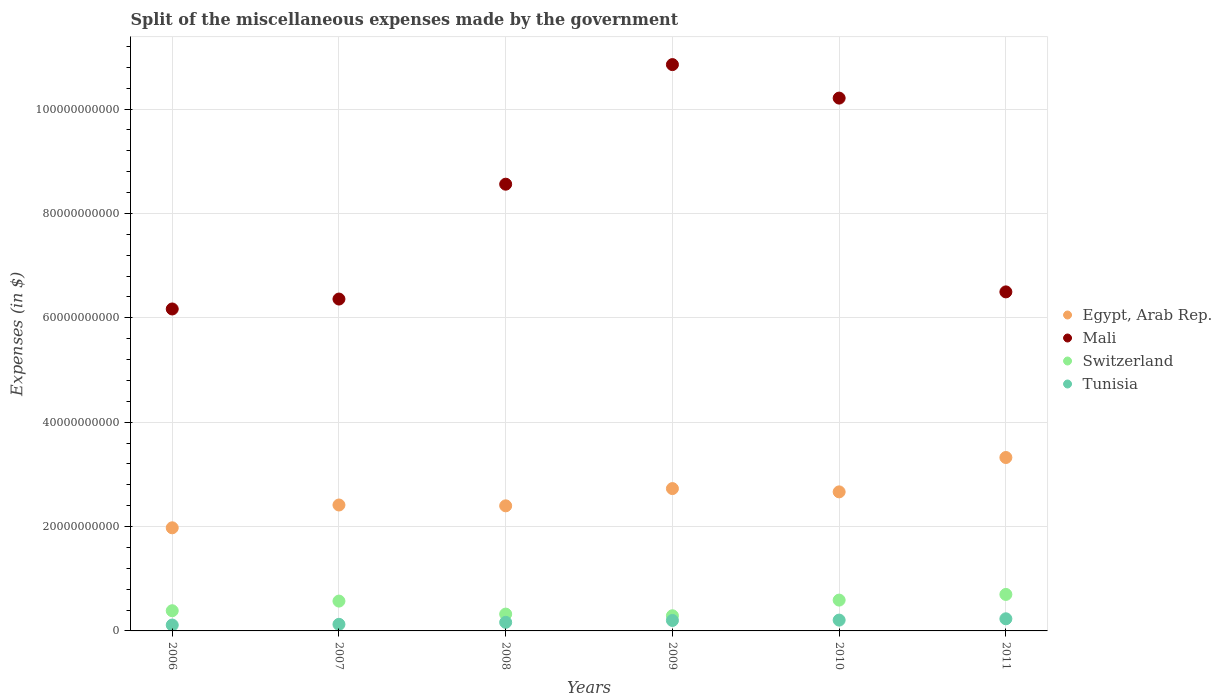How many different coloured dotlines are there?
Make the answer very short. 4. What is the miscellaneous expenses made by the government in Tunisia in 2010?
Provide a short and direct response. 2.07e+09. Across all years, what is the maximum miscellaneous expenses made by the government in Tunisia?
Your response must be concise. 2.32e+09. Across all years, what is the minimum miscellaneous expenses made by the government in Tunisia?
Your answer should be compact. 1.13e+09. In which year was the miscellaneous expenses made by the government in Switzerland minimum?
Ensure brevity in your answer.  2009. What is the total miscellaneous expenses made by the government in Mali in the graph?
Keep it short and to the point. 4.87e+11. What is the difference between the miscellaneous expenses made by the government in Tunisia in 2007 and that in 2008?
Keep it short and to the point. -3.80e+08. What is the difference between the miscellaneous expenses made by the government in Tunisia in 2006 and the miscellaneous expenses made by the government in Egypt, Arab Rep. in 2010?
Your answer should be compact. -2.55e+1. What is the average miscellaneous expenses made by the government in Mali per year?
Provide a succinct answer. 8.11e+1. In the year 2009, what is the difference between the miscellaneous expenses made by the government in Mali and miscellaneous expenses made by the government in Tunisia?
Your answer should be very brief. 1.07e+11. In how many years, is the miscellaneous expenses made by the government in Switzerland greater than 100000000000 $?
Your answer should be compact. 0. What is the ratio of the miscellaneous expenses made by the government in Mali in 2006 to that in 2007?
Your response must be concise. 0.97. Is the difference between the miscellaneous expenses made by the government in Mali in 2007 and 2009 greater than the difference between the miscellaneous expenses made by the government in Tunisia in 2007 and 2009?
Your answer should be compact. No. What is the difference between the highest and the second highest miscellaneous expenses made by the government in Switzerland?
Your response must be concise. 1.09e+09. What is the difference between the highest and the lowest miscellaneous expenses made by the government in Switzerland?
Offer a very short reply. 4.09e+09. Is the sum of the miscellaneous expenses made by the government in Tunisia in 2006 and 2008 greater than the maximum miscellaneous expenses made by the government in Switzerland across all years?
Give a very brief answer. No. Is it the case that in every year, the sum of the miscellaneous expenses made by the government in Switzerland and miscellaneous expenses made by the government in Egypt, Arab Rep.  is greater than the sum of miscellaneous expenses made by the government in Tunisia and miscellaneous expenses made by the government in Mali?
Offer a terse response. Yes. Does the miscellaneous expenses made by the government in Tunisia monotonically increase over the years?
Your answer should be compact. Yes. How many dotlines are there?
Offer a terse response. 4. How many years are there in the graph?
Give a very brief answer. 6. Are the values on the major ticks of Y-axis written in scientific E-notation?
Provide a short and direct response. No. Does the graph contain any zero values?
Your answer should be compact. No. Does the graph contain grids?
Make the answer very short. Yes. What is the title of the graph?
Your answer should be very brief. Split of the miscellaneous expenses made by the government. What is the label or title of the Y-axis?
Give a very brief answer. Expenses (in $). What is the Expenses (in $) of Egypt, Arab Rep. in 2006?
Your answer should be compact. 1.98e+1. What is the Expenses (in $) in Mali in 2006?
Your answer should be compact. 6.17e+1. What is the Expenses (in $) of Switzerland in 2006?
Your answer should be very brief. 3.87e+09. What is the Expenses (in $) of Tunisia in 2006?
Provide a succinct answer. 1.13e+09. What is the Expenses (in $) in Egypt, Arab Rep. in 2007?
Offer a terse response. 2.41e+1. What is the Expenses (in $) of Mali in 2007?
Your answer should be compact. 6.36e+1. What is the Expenses (in $) in Switzerland in 2007?
Your response must be concise. 5.72e+09. What is the Expenses (in $) of Tunisia in 2007?
Your answer should be compact. 1.26e+09. What is the Expenses (in $) of Egypt, Arab Rep. in 2008?
Give a very brief answer. 2.40e+1. What is the Expenses (in $) in Mali in 2008?
Offer a very short reply. 8.56e+1. What is the Expenses (in $) in Switzerland in 2008?
Offer a terse response. 3.22e+09. What is the Expenses (in $) of Tunisia in 2008?
Give a very brief answer. 1.64e+09. What is the Expenses (in $) in Egypt, Arab Rep. in 2009?
Provide a succinct answer. 2.73e+1. What is the Expenses (in $) in Mali in 2009?
Make the answer very short. 1.09e+11. What is the Expenses (in $) of Switzerland in 2009?
Make the answer very short. 2.91e+09. What is the Expenses (in $) of Tunisia in 2009?
Your answer should be very brief. 2.00e+09. What is the Expenses (in $) of Egypt, Arab Rep. in 2010?
Give a very brief answer. 2.66e+1. What is the Expenses (in $) of Mali in 2010?
Offer a terse response. 1.02e+11. What is the Expenses (in $) in Switzerland in 2010?
Your answer should be compact. 5.91e+09. What is the Expenses (in $) of Tunisia in 2010?
Give a very brief answer. 2.07e+09. What is the Expenses (in $) of Egypt, Arab Rep. in 2011?
Give a very brief answer. 3.32e+1. What is the Expenses (in $) in Mali in 2011?
Provide a succinct answer. 6.50e+1. What is the Expenses (in $) in Switzerland in 2011?
Provide a succinct answer. 6.99e+09. What is the Expenses (in $) of Tunisia in 2011?
Make the answer very short. 2.32e+09. Across all years, what is the maximum Expenses (in $) of Egypt, Arab Rep.?
Provide a short and direct response. 3.32e+1. Across all years, what is the maximum Expenses (in $) of Mali?
Your response must be concise. 1.09e+11. Across all years, what is the maximum Expenses (in $) of Switzerland?
Give a very brief answer. 6.99e+09. Across all years, what is the maximum Expenses (in $) of Tunisia?
Your answer should be compact. 2.32e+09. Across all years, what is the minimum Expenses (in $) in Egypt, Arab Rep.?
Provide a succinct answer. 1.98e+1. Across all years, what is the minimum Expenses (in $) of Mali?
Give a very brief answer. 6.17e+1. Across all years, what is the minimum Expenses (in $) of Switzerland?
Offer a terse response. 2.91e+09. Across all years, what is the minimum Expenses (in $) of Tunisia?
Give a very brief answer. 1.13e+09. What is the total Expenses (in $) of Egypt, Arab Rep. in the graph?
Give a very brief answer. 1.55e+11. What is the total Expenses (in $) of Mali in the graph?
Your answer should be compact. 4.87e+11. What is the total Expenses (in $) of Switzerland in the graph?
Your answer should be compact. 2.86e+1. What is the total Expenses (in $) in Tunisia in the graph?
Give a very brief answer. 1.04e+1. What is the difference between the Expenses (in $) in Egypt, Arab Rep. in 2006 and that in 2007?
Ensure brevity in your answer.  -4.37e+09. What is the difference between the Expenses (in $) in Mali in 2006 and that in 2007?
Your answer should be compact. -1.90e+09. What is the difference between the Expenses (in $) in Switzerland in 2006 and that in 2007?
Ensure brevity in your answer.  -1.85e+09. What is the difference between the Expenses (in $) of Tunisia in 2006 and that in 2007?
Your answer should be compact. -1.37e+08. What is the difference between the Expenses (in $) of Egypt, Arab Rep. in 2006 and that in 2008?
Provide a short and direct response. -4.21e+09. What is the difference between the Expenses (in $) of Mali in 2006 and that in 2008?
Your answer should be very brief. -2.39e+1. What is the difference between the Expenses (in $) of Switzerland in 2006 and that in 2008?
Give a very brief answer. 6.45e+08. What is the difference between the Expenses (in $) of Tunisia in 2006 and that in 2008?
Provide a succinct answer. -5.17e+08. What is the difference between the Expenses (in $) of Egypt, Arab Rep. in 2006 and that in 2009?
Your answer should be compact. -7.51e+09. What is the difference between the Expenses (in $) in Mali in 2006 and that in 2009?
Provide a succinct answer. -4.68e+1. What is the difference between the Expenses (in $) of Switzerland in 2006 and that in 2009?
Offer a very short reply. 9.64e+08. What is the difference between the Expenses (in $) in Tunisia in 2006 and that in 2009?
Provide a short and direct response. -8.77e+08. What is the difference between the Expenses (in $) of Egypt, Arab Rep. in 2006 and that in 2010?
Offer a terse response. -6.89e+09. What is the difference between the Expenses (in $) in Mali in 2006 and that in 2010?
Make the answer very short. -4.04e+1. What is the difference between the Expenses (in $) in Switzerland in 2006 and that in 2010?
Give a very brief answer. -2.04e+09. What is the difference between the Expenses (in $) of Tunisia in 2006 and that in 2010?
Your response must be concise. -9.48e+08. What is the difference between the Expenses (in $) of Egypt, Arab Rep. in 2006 and that in 2011?
Provide a short and direct response. -1.35e+1. What is the difference between the Expenses (in $) of Mali in 2006 and that in 2011?
Your response must be concise. -3.27e+09. What is the difference between the Expenses (in $) in Switzerland in 2006 and that in 2011?
Ensure brevity in your answer.  -3.12e+09. What is the difference between the Expenses (in $) of Tunisia in 2006 and that in 2011?
Keep it short and to the point. -1.20e+09. What is the difference between the Expenses (in $) in Egypt, Arab Rep. in 2007 and that in 2008?
Offer a terse response. 1.59e+08. What is the difference between the Expenses (in $) of Mali in 2007 and that in 2008?
Provide a short and direct response. -2.20e+1. What is the difference between the Expenses (in $) in Switzerland in 2007 and that in 2008?
Ensure brevity in your answer.  2.49e+09. What is the difference between the Expenses (in $) in Tunisia in 2007 and that in 2008?
Provide a succinct answer. -3.80e+08. What is the difference between the Expenses (in $) of Egypt, Arab Rep. in 2007 and that in 2009?
Offer a very short reply. -3.14e+09. What is the difference between the Expenses (in $) of Mali in 2007 and that in 2009?
Provide a short and direct response. -4.49e+1. What is the difference between the Expenses (in $) of Switzerland in 2007 and that in 2009?
Keep it short and to the point. 2.81e+09. What is the difference between the Expenses (in $) in Tunisia in 2007 and that in 2009?
Provide a short and direct response. -7.40e+08. What is the difference between the Expenses (in $) of Egypt, Arab Rep. in 2007 and that in 2010?
Your answer should be compact. -2.52e+09. What is the difference between the Expenses (in $) in Mali in 2007 and that in 2010?
Your answer should be very brief. -3.85e+1. What is the difference between the Expenses (in $) in Switzerland in 2007 and that in 2010?
Your answer should be compact. -1.89e+08. What is the difference between the Expenses (in $) in Tunisia in 2007 and that in 2010?
Your answer should be compact. -8.11e+08. What is the difference between the Expenses (in $) of Egypt, Arab Rep. in 2007 and that in 2011?
Your answer should be compact. -9.10e+09. What is the difference between the Expenses (in $) of Mali in 2007 and that in 2011?
Offer a very short reply. -1.37e+09. What is the difference between the Expenses (in $) of Switzerland in 2007 and that in 2011?
Make the answer very short. -1.28e+09. What is the difference between the Expenses (in $) in Tunisia in 2007 and that in 2011?
Your answer should be compact. -1.06e+09. What is the difference between the Expenses (in $) in Egypt, Arab Rep. in 2008 and that in 2009?
Your answer should be very brief. -3.30e+09. What is the difference between the Expenses (in $) of Mali in 2008 and that in 2009?
Keep it short and to the point. -2.29e+1. What is the difference between the Expenses (in $) of Switzerland in 2008 and that in 2009?
Offer a very short reply. 3.19e+08. What is the difference between the Expenses (in $) in Tunisia in 2008 and that in 2009?
Your answer should be very brief. -3.60e+08. What is the difference between the Expenses (in $) of Egypt, Arab Rep. in 2008 and that in 2010?
Provide a succinct answer. -2.67e+09. What is the difference between the Expenses (in $) in Mali in 2008 and that in 2010?
Provide a succinct answer. -1.65e+1. What is the difference between the Expenses (in $) in Switzerland in 2008 and that in 2010?
Provide a succinct answer. -2.68e+09. What is the difference between the Expenses (in $) in Tunisia in 2008 and that in 2010?
Keep it short and to the point. -4.31e+08. What is the difference between the Expenses (in $) of Egypt, Arab Rep. in 2008 and that in 2011?
Provide a short and direct response. -9.26e+09. What is the difference between the Expenses (in $) of Mali in 2008 and that in 2011?
Offer a terse response. 2.06e+1. What is the difference between the Expenses (in $) in Switzerland in 2008 and that in 2011?
Provide a succinct answer. -3.77e+09. What is the difference between the Expenses (in $) in Tunisia in 2008 and that in 2011?
Provide a succinct answer. -6.82e+08. What is the difference between the Expenses (in $) in Egypt, Arab Rep. in 2009 and that in 2010?
Your answer should be very brief. 6.29e+08. What is the difference between the Expenses (in $) of Mali in 2009 and that in 2010?
Offer a very short reply. 6.42e+09. What is the difference between the Expenses (in $) in Switzerland in 2009 and that in 2010?
Make the answer very short. -3.00e+09. What is the difference between the Expenses (in $) in Tunisia in 2009 and that in 2010?
Give a very brief answer. -7.06e+07. What is the difference between the Expenses (in $) of Egypt, Arab Rep. in 2009 and that in 2011?
Provide a short and direct response. -5.96e+09. What is the difference between the Expenses (in $) of Mali in 2009 and that in 2011?
Ensure brevity in your answer.  4.36e+1. What is the difference between the Expenses (in $) of Switzerland in 2009 and that in 2011?
Your response must be concise. -4.09e+09. What is the difference between the Expenses (in $) of Tunisia in 2009 and that in 2011?
Provide a short and direct response. -3.21e+08. What is the difference between the Expenses (in $) of Egypt, Arab Rep. in 2010 and that in 2011?
Offer a very short reply. -6.59e+09. What is the difference between the Expenses (in $) in Mali in 2010 and that in 2011?
Offer a very short reply. 3.71e+1. What is the difference between the Expenses (in $) in Switzerland in 2010 and that in 2011?
Provide a short and direct response. -1.09e+09. What is the difference between the Expenses (in $) of Tunisia in 2010 and that in 2011?
Make the answer very short. -2.50e+08. What is the difference between the Expenses (in $) of Egypt, Arab Rep. in 2006 and the Expenses (in $) of Mali in 2007?
Your response must be concise. -4.38e+1. What is the difference between the Expenses (in $) in Egypt, Arab Rep. in 2006 and the Expenses (in $) in Switzerland in 2007?
Provide a short and direct response. 1.40e+1. What is the difference between the Expenses (in $) in Egypt, Arab Rep. in 2006 and the Expenses (in $) in Tunisia in 2007?
Provide a short and direct response. 1.85e+1. What is the difference between the Expenses (in $) of Mali in 2006 and the Expenses (in $) of Switzerland in 2007?
Provide a succinct answer. 5.60e+1. What is the difference between the Expenses (in $) of Mali in 2006 and the Expenses (in $) of Tunisia in 2007?
Your answer should be very brief. 6.04e+1. What is the difference between the Expenses (in $) in Switzerland in 2006 and the Expenses (in $) in Tunisia in 2007?
Offer a terse response. 2.61e+09. What is the difference between the Expenses (in $) of Egypt, Arab Rep. in 2006 and the Expenses (in $) of Mali in 2008?
Your answer should be compact. -6.58e+1. What is the difference between the Expenses (in $) in Egypt, Arab Rep. in 2006 and the Expenses (in $) in Switzerland in 2008?
Make the answer very short. 1.65e+1. What is the difference between the Expenses (in $) of Egypt, Arab Rep. in 2006 and the Expenses (in $) of Tunisia in 2008?
Your answer should be compact. 1.81e+1. What is the difference between the Expenses (in $) in Mali in 2006 and the Expenses (in $) in Switzerland in 2008?
Offer a terse response. 5.85e+1. What is the difference between the Expenses (in $) in Mali in 2006 and the Expenses (in $) in Tunisia in 2008?
Provide a short and direct response. 6.01e+1. What is the difference between the Expenses (in $) of Switzerland in 2006 and the Expenses (in $) of Tunisia in 2008?
Provide a succinct answer. 2.23e+09. What is the difference between the Expenses (in $) of Egypt, Arab Rep. in 2006 and the Expenses (in $) of Mali in 2009?
Make the answer very short. -8.88e+1. What is the difference between the Expenses (in $) in Egypt, Arab Rep. in 2006 and the Expenses (in $) in Switzerland in 2009?
Your answer should be compact. 1.69e+1. What is the difference between the Expenses (in $) of Egypt, Arab Rep. in 2006 and the Expenses (in $) of Tunisia in 2009?
Make the answer very short. 1.78e+1. What is the difference between the Expenses (in $) in Mali in 2006 and the Expenses (in $) in Switzerland in 2009?
Your answer should be very brief. 5.88e+1. What is the difference between the Expenses (in $) in Mali in 2006 and the Expenses (in $) in Tunisia in 2009?
Your response must be concise. 5.97e+1. What is the difference between the Expenses (in $) in Switzerland in 2006 and the Expenses (in $) in Tunisia in 2009?
Keep it short and to the point. 1.87e+09. What is the difference between the Expenses (in $) in Egypt, Arab Rep. in 2006 and the Expenses (in $) in Mali in 2010?
Keep it short and to the point. -8.23e+1. What is the difference between the Expenses (in $) in Egypt, Arab Rep. in 2006 and the Expenses (in $) in Switzerland in 2010?
Make the answer very short. 1.39e+1. What is the difference between the Expenses (in $) in Egypt, Arab Rep. in 2006 and the Expenses (in $) in Tunisia in 2010?
Your response must be concise. 1.77e+1. What is the difference between the Expenses (in $) in Mali in 2006 and the Expenses (in $) in Switzerland in 2010?
Provide a short and direct response. 5.58e+1. What is the difference between the Expenses (in $) of Mali in 2006 and the Expenses (in $) of Tunisia in 2010?
Ensure brevity in your answer.  5.96e+1. What is the difference between the Expenses (in $) of Switzerland in 2006 and the Expenses (in $) of Tunisia in 2010?
Your response must be concise. 1.79e+09. What is the difference between the Expenses (in $) of Egypt, Arab Rep. in 2006 and the Expenses (in $) of Mali in 2011?
Ensure brevity in your answer.  -4.52e+1. What is the difference between the Expenses (in $) in Egypt, Arab Rep. in 2006 and the Expenses (in $) in Switzerland in 2011?
Offer a very short reply. 1.28e+1. What is the difference between the Expenses (in $) in Egypt, Arab Rep. in 2006 and the Expenses (in $) in Tunisia in 2011?
Keep it short and to the point. 1.74e+1. What is the difference between the Expenses (in $) in Mali in 2006 and the Expenses (in $) in Switzerland in 2011?
Provide a succinct answer. 5.47e+1. What is the difference between the Expenses (in $) of Mali in 2006 and the Expenses (in $) of Tunisia in 2011?
Ensure brevity in your answer.  5.94e+1. What is the difference between the Expenses (in $) in Switzerland in 2006 and the Expenses (in $) in Tunisia in 2011?
Provide a succinct answer. 1.54e+09. What is the difference between the Expenses (in $) in Egypt, Arab Rep. in 2007 and the Expenses (in $) in Mali in 2008?
Provide a short and direct response. -6.15e+1. What is the difference between the Expenses (in $) of Egypt, Arab Rep. in 2007 and the Expenses (in $) of Switzerland in 2008?
Your answer should be very brief. 2.09e+1. What is the difference between the Expenses (in $) in Egypt, Arab Rep. in 2007 and the Expenses (in $) in Tunisia in 2008?
Your answer should be compact. 2.25e+1. What is the difference between the Expenses (in $) in Mali in 2007 and the Expenses (in $) in Switzerland in 2008?
Your answer should be very brief. 6.04e+1. What is the difference between the Expenses (in $) of Mali in 2007 and the Expenses (in $) of Tunisia in 2008?
Provide a short and direct response. 6.20e+1. What is the difference between the Expenses (in $) of Switzerland in 2007 and the Expenses (in $) of Tunisia in 2008?
Keep it short and to the point. 4.07e+09. What is the difference between the Expenses (in $) in Egypt, Arab Rep. in 2007 and the Expenses (in $) in Mali in 2009?
Provide a succinct answer. -8.44e+1. What is the difference between the Expenses (in $) in Egypt, Arab Rep. in 2007 and the Expenses (in $) in Switzerland in 2009?
Give a very brief answer. 2.12e+1. What is the difference between the Expenses (in $) in Egypt, Arab Rep. in 2007 and the Expenses (in $) in Tunisia in 2009?
Your answer should be very brief. 2.21e+1. What is the difference between the Expenses (in $) of Mali in 2007 and the Expenses (in $) of Switzerland in 2009?
Ensure brevity in your answer.  6.07e+1. What is the difference between the Expenses (in $) in Mali in 2007 and the Expenses (in $) in Tunisia in 2009?
Your response must be concise. 6.16e+1. What is the difference between the Expenses (in $) of Switzerland in 2007 and the Expenses (in $) of Tunisia in 2009?
Offer a very short reply. 3.71e+09. What is the difference between the Expenses (in $) in Egypt, Arab Rep. in 2007 and the Expenses (in $) in Mali in 2010?
Offer a very short reply. -7.80e+1. What is the difference between the Expenses (in $) of Egypt, Arab Rep. in 2007 and the Expenses (in $) of Switzerland in 2010?
Give a very brief answer. 1.82e+1. What is the difference between the Expenses (in $) of Egypt, Arab Rep. in 2007 and the Expenses (in $) of Tunisia in 2010?
Make the answer very short. 2.21e+1. What is the difference between the Expenses (in $) of Mali in 2007 and the Expenses (in $) of Switzerland in 2010?
Ensure brevity in your answer.  5.77e+1. What is the difference between the Expenses (in $) in Mali in 2007 and the Expenses (in $) in Tunisia in 2010?
Offer a very short reply. 6.15e+1. What is the difference between the Expenses (in $) of Switzerland in 2007 and the Expenses (in $) of Tunisia in 2010?
Offer a terse response. 3.64e+09. What is the difference between the Expenses (in $) of Egypt, Arab Rep. in 2007 and the Expenses (in $) of Mali in 2011?
Keep it short and to the point. -4.08e+1. What is the difference between the Expenses (in $) of Egypt, Arab Rep. in 2007 and the Expenses (in $) of Switzerland in 2011?
Provide a succinct answer. 1.71e+1. What is the difference between the Expenses (in $) of Egypt, Arab Rep. in 2007 and the Expenses (in $) of Tunisia in 2011?
Provide a succinct answer. 2.18e+1. What is the difference between the Expenses (in $) in Mali in 2007 and the Expenses (in $) in Switzerland in 2011?
Make the answer very short. 5.66e+1. What is the difference between the Expenses (in $) in Mali in 2007 and the Expenses (in $) in Tunisia in 2011?
Keep it short and to the point. 6.13e+1. What is the difference between the Expenses (in $) of Switzerland in 2007 and the Expenses (in $) of Tunisia in 2011?
Provide a succinct answer. 3.39e+09. What is the difference between the Expenses (in $) of Egypt, Arab Rep. in 2008 and the Expenses (in $) of Mali in 2009?
Provide a short and direct response. -8.46e+1. What is the difference between the Expenses (in $) in Egypt, Arab Rep. in 2008 and the Expenses (in $) in Switzerland in 2009?
Offer a very short reply. 2.11e+1. What is the difference between the Expenses (in $) of Egypt, Arab Rep. in 2008 and the Expenses (in $) of Tunisia in 2009?
Offer a very short reply. 2.20e+1. What is the difference between the Expenses (in $) of Mali in 2008 and the Expenses (in $) of Switzerland in 2009?
Offer a terse response. 8.27e+1. What is the difference between the Expenses (in $) in Mali in 2008 and the Expenses (in $) in Tunisia in 2009?
Your answer should be compact. 8.36e+1. What is the difference between the Expenses (in $) in Switzerland in 2008 and the Expenses (in $) in Tunisia in 2009?
Offer a terse response. 1.22e+09. What is the difference between the Expenses (in $) in Egypt, Arab Rep. in 2008 and the Expenses (in $) in Mali in 2010?
Keep it short and to the point. -7.81e+1. What is the difference between the Expenses (in $) of Egypt, Arab Rep. in 2008 and the Expenses (in $) of Switzerland in 2010?
Offer a terse response. 1.81e+1. What is the difference between the Expenses (in $) in Egypt, Arab Rep. in 2008 and the Expenses (in $) in Tunisia in 2010?
Offer a very short reply. 2.19e+1. What is the difference between the Expenses (in $) in Mali in 2008 and the Expenses (in $) in Switzerland in 2010?
Make the answer very short. 7.97e+1. What is the difference between the Expenses (in $) of Mali in 2008 and the Expenses (in $) of Tunisia in 2010?
Provide a succinct answer. 8.35e+1. What is the difference between the Expenses (in $) in Switzerland in 2008 and the Expenses (in $) in Tunisia in 2010?
Your answer should be compact. 1.15e+09. What is the difference between the Expenses (in $) in Egypt, Arab Rep. in 2008 and the Expenses (in $) in Mali in 2011?
Your answer should be compact. -4.10e+1. What is the difference between the Expenses (in $) in Egypt, Arab Rep. in 2008 and the Expenses (in $) in Switzerland in 2011?
Your answer should be compact. 1.70e+1. What is the difference between the Expenses (in $) in Egypt, Arab Rep. in 2008 and the Expenses (in $) in Tunisia in 2011?
Offer a very short reply. 2.16e+1. What is the difference between the Expenses (in $) of Mali in 2008 and the Expenses (in $) of Switzerland in 2011?
Offer a terse response. 7.86e+1. What is the difference between the Expenses (in $) of Mali in 2008 and the Expenses (in $) of Tunisia in 2011?
Your answer should be compact. 8.33e+1. What is the difference between the Expenses (in $) in Switzerland in 2008 and the Expenses (in $) in Tunisia in 2011?
Make the answer very short. 8.99e+08. What is the difference between the Expenses (in $) of Egypt, Arab Rep. in 2009 and the Expenses (in $) of Mali in 2010?
Ensure brevity in your answer.  -7.48e+1. What is the difference between the Expenses (in $) of Egypt, Arab Rep. in 2009 and the Expenses (in $) of Switzerland in 2010?
Keep it short and to the point. 2.14e+1. What is the difference between the Expenses (in $) of Egypt, Arab Rep. in 2009 and the Expenses (in $) of Tunisia in 2010?
Keep it short and to the point. 2.52e+1. What is the difference between the Expenses (in $) in Mali in 2009 and the Expenses (in $) in Switzerland in 2010?
Ensure brevity in your answer.  1.03e+11. What is the difference between the Expenses (in $) of Mali in 2009 and the Expenses (in $) of Tunisia in 2010?
Offer a terse response. 1.06e+11. What is the difference between the Expenses (in $) in Switzerland in 2009 and the Expenses (in $) in Tunisia in 2010?
Provide a short and direct response. 8.31e+08. What is the difference between the Expenses (in $) in Egypt, Arab Rep. in 2009 and the Expenses (in $) in Mali in 2011?
Your response must be concise. -3.77e+1. What is the difference between the Expenses (in $) of Egypt, Arab Rep. in 2009 and the Expenses (in $) of Switzerland in 2011?
Your answer should be very brief. 2.03e+1. What is the difference between the Expenses (in $) in Egypt, Arab Rep. in 2009 and the Expenses (in $) in Tunisia in 2011?
Provide a short and direct response. 2.50e+1. What is the difference between the Expenses (in $) in Mali in 2009 and the Expenses (in $) in Switzerland in 2011?
Your answer should be very brief. 1.02e+11. What is the difference between the Expenses (in $) in Mali in 2009 and the Expenses (in $) in Tunisia in 2011?
Keep it short and to the point. 1.06e+11. What is the difference between the Expenses (in $) of Switzerland in 2009 and the Expenses (in $) of Tunisia in 2011?
Offer a terse response. 5.80e+08. What is the difference between the Expenses (in $) of Egypt, Arab Rep. in 2010 and the Expenses (in $) of Mali in 2011?
Offer a very short reply. -3.83e+1. What is the difference between the Expenses (in $) in Egypt, Arab Rep. in 2010 and the Expenses (in $) in Switzerland in 2011?
Keep it short and to the point. 1.97e+1. What is the difference between the Expenses (in $) in Egypt, Arab Rep. in 2010 and the Expenses (in $) in Tunisia in 2011?
Provide a succinct answer. 2.43e+1. What is the difference between the Expenses (in $) of Mali in 2010 and the Expenses (in $) of Switzerland in 2011?
Your response must be concise. 9.51e+1. What is the difference between the Expenses (in $) of Mali in 2010 and the Expenses (in $) of Tunisia in 2011?
Your answer should be very brief. 9.98e+1. What is the difference between the Expenses (in $) of Switzerland in 2010 and the Expenses (in $) of Tunisia in 2011?
Your answer should be compact. 3.58e+09. What is the average Expenses (in $) of Egypt, Arab Rep. per year?
Provide a short and direct response. 2.58e+1. What is the average Expenses (in $) in Mali per year?
Your response must be concise. 8.11e+1. What is the average Expenses (in $) in Switzerland per year?
Ensure brevity in your answer.  4.77e+09. What is the average Expenses (in $) in Tunisia per year?
Make the answer very short. 1.74e+09. In the year 2006, what is the difference between the Expenses (in $) in Egypt, Arab Rep. and Expenses (in $) in Mali?
Give a very brief answer. -4.19e+1. In the year 2006, what is the difference between the Expenses (in $) in Egypt, Arab Rep. and Expenses (in $) in Switzerland?
Make the answer very short. 1.59e+1. In the year 2006, what is the difference between the Expenses (in $) of Egypt, Arab Rep. and Expenses (in $) of Tunisia?
Keep it short and to the point. 1.86e+1. In the year 2006, what is the difference between the Expenses (in $) of Mali and Expenses (in $) of Switzerland?
Give a very brief answer. 5.78e+1. In the year 2006, what is the difference between the Expenses (in $) of Mali and Expenses (in $) of Tunisia?
Make the answer very short. 6.06e+1. In the year 2006, what is the difference between the Expenses (in $) in Switzerland and Expenses (in $) in Tunisia?
Provide a succinct answer. 2.74e+09. In the year 2007, what is the difference between the Expenses (in $) in Egypt, Arab Rep. and Expenses (in $) in Mali?
Offer a very short reply. -3.95e+1. In the year 2007, what is the difference between the Expenses (in $) in Egypt, Arab Rep. and Expenses (in $) in Switzerland?
Give a very brief answer. 1.84e+1. In the year 2007, what is the difference between the Expenses (in $) in Egypt, Arab Rep. and Expenses (in $) in Tunisia?
Offer a very short reply. 2.29e+1. In the year 2007, what is the difference between the Expenses (in $) in Mali and Expenses (in $) in Switzerland?
Your response must be concise. 5.79e+1. In the year 2007, what is the difference between the Expenses (in $) in Mali and Expenses (in $) in Tunisia?
Ensure brevity in your answer.  6.23e+1. In the year 2007, what is the difference between the Expenses (in $) in Switzerland and Expenses (in $) in Tunisia?
Offer a terse response. 4.45e+09. In the year 2008, what is the difference between the Expenses (in $) of Egypt, Arab Rep. and Expenses (in $) of Mali?
Ensure brevity in your answer.  -6.16e+1. In the year 2008, what is the difference between the Expenses (in $) of Egypt, Arab Rep. and Expenses (in $) of Switzerland?
Offer a very short reply. 2.07e+1. In the year 2008, what is the difference between the Expenses (in $) of Egypt, Arab Rep. and Expenses (in $) of Tunisia?
Offer a very short reply. 2.23e+1. In the year 2008, what is the difference between the Expenses (in $) in Mali and Expenses (in $) in Switzerland?
Provide a succinct answer. 8.24e+1. In the year 2008, what is the difference between the Expenses (in $) in Mali and Expenses (in $) in Tunisia?
Offer a terse response. 8.40e+1. In the year 2008, what is the difference between the Expenses (in $) of Switzerland and Expenses (in $) of Tunisia?
Your answer should be very brief. 1.58e+09. In the year 2009, what is the difference between the Expenses (in $) of Egypt, Arab Rep. and Expenses (in $) of Mali?
Provide a succinct answer. -8.13e+1. In the year 2009, what is the difference between the Expenses (in $) of Egypt, Arab Rep. and Expenses (in $) of Switzerland?
Your answer should be compact. 2.44e+1. In the year 2009, what is the difference between the Expenses (in $) of Egypt, Arab Rep. and Expenses (in $) of Tunisia?
Your response must be concise. 2.53e+1. In the year 2009, what is the difference between the Expenses (in $) in Mali and Expenses (in $) in Switzerland?
Give a very brief answer. 1.06e+11. In the year 2009, what is the difference between the Expenses (in $) of Mali and Expenses (in $) of Tunisia?
Keep it short and to the point. 1.07e+11. In the year 2009, what is the difference between the Expenses (in $) in Switzerland and Expenses (in $) in Tunisia?
Offer a terse response. 9.01e+08. In the year 2010, what is the difference between the Expenses (in $) of Egypt, Arab Rep. and Expenses (in $) of Mali?
Ensure brevity in your answer.  -7.55e+1. In the year 2010, what is the difference between the Expenses (in $) of Egypt, Arab Rep. and Expenses (in $) of Switzerland?
Keep it short and to the point. 2.07e+1. In the year 2010, what is the difference between the Expenses (in $) in Egypt, Arab Rep. and Expenses (in $) in Tunisia?
Make the answer very short. 2.46e+1. In the year 2010, what is the difference between the Expenses (in $) of Mali and Expenses (in $) of Switzerland?
Your response must be concise. 9.62e+1. In the year 2010, what is the difference between the Expenses (in $) of Mali and Expenses (in $) of Tunisia?
Provide a short and direct response. 1.00e+11. In the year 2010, what is the difference between the Expenses (in $) of Switzerland and Expenses (in $) of Tunisia?
Your response must be concise. 3.83e+09. In the year 2011, what is the difference between the Expenses (in $) in Egypt, Arab Rep. and Expenses (in $) in Mali?
Keep it short and to the point. -3.17e+1. In the year 2011, what is the difference between the Expenses (in $) in Egypt, Arab Rep. and Expenses (in $) in Switzerland?
Make the answer very short. 2.62e+1. In the year 2011, what is the difference between the Expenses (in $) in Egypt, Arab Rep. and Expenses (in $) in Tunisia?
Ensure brevity in your answer.  3.09e+1. In the year 2011, what is the difference between the Expenses (in $) in Mali and Expenses (in $) in Switzerland?
Ensure brevity in your answer.  5.80e+1. In the year 2011, what is the difference between the Expenses (in $) of Mali and Expenses (in $) of Tunisia?
Offer a very short reply. 6.26e+1. In the year 2011, what is the difference between the Expenses (in $) of Switzerland and Expenses (in $) of Tunisia?
Offer a very short reply. 4.67e+09. What is the ratio of the Expenses (in $) of Egypt, Arab Rep. in 2006 to that in 2007?
Your response must be concise. 0.82. What is the ratio of the Expenses (in $) of Mali in 2006 to that in 2007?
Provide a succinct answer. 0.97. What is the ratio of the Expenses (in $) in Switzerland in 2006 to that in 2007?
Keep it short and to the point. 0.68. What is the ratio of the Expenses (in $) in Tunisia in 2006 to that in 2007?
Offer a terse response. 0.89. What is the ratio of the Expenses (in $) of Egypt, Arab Rep. in 2006 to that in 2008?
Ensure brevity in your answer.  0.82. What is the ratio of the Expenses (in $) in Mali in 2006 to that in 2008?
Your response must be concise. 0.72. What is the ratio of the Expenses (in $) in Switzerland in 2006 to that in 2008?
Give a very brief answer. 1.2. What is the ratio of the Expenses (in $) of Tunisia in 2006 to that in 2008?
Offer a terse response. 0.69. What is the ratio of the Expenses (in $) of Egypt, Arab Rep. in 2006 to that in 2009?
Make the answer very short. 0.72. What is the ratio of the Expenses (in $) in Mali in 2006 to that in 2009?
Give a very brief answer. 0.57. What is the ratio of the Expenses (in $) of Switzerland in 2006 to that in 2009?
Provide a succinct answer. 1.33. What is the ratio of the Expenses (in $) in Tunisia in 2006 to that in 2009?
Keep it short and to the point. 0.56. What is the ratio of the Expenses (in $) in Egypt, Arab Rep. in 2006 to that in 2010?
Give a very brief answer. 0.74. What is the ratio of the Expenses (in $) of Mali in 2006 to that in 2010?
Offer a very short reply. 0.6. What is the ratio of the Expenses (in $) in Switzerland in 2006 to that in 2010?
Offer a terse response. 0.66. What is the ratio of the Expenses (in $) of Tunisia in 2006 to that in 2010?
Your answer should be compact. 0.54. What is the ratio of the Expenses (in $) of Egypt, Arab Rep. in 2006 to that in 2011?
Provide a succinct answer. 0.59. What is the ratio of the Expenses (in $) in Mali in 2006 to that in 2011?
Ensure brevity in your answer.  0.95. What is the ratio of the Expenses (in $) in Switzerland in 2006 to that in 2011?
Offer a terse response. 0.55. What is the ratio of the Expenses (in $) in Tunisia in 2006 to that in 2011?
Ensure brevity in your answer.  0.48. What is the ratio of the Expenses (in $) of Egypt, Arab Rep. in 2007 to that in 2008?
Your response must be concise. 1.01. What is the ratio of the Expenses (in $) in Mali in 2007 to that in 2008?
Provide a short and direct response. 0.74. What is the ratio of the Expenses (in $) in Switzerland in 2007 to that in 2008?
Your answer should be very brief. 1.77. What is the ratio of the Expenses (in $) in Tunisia in 2007 to that in 2008?
Keep it short and to the point. 0.77. What is the ratio of the Expenses (in $) of Egypt, Arab Rep. in 2007 to that in 2009?
Provide a short and direct response. 0.88. What is the ratio of the Expenses (in $) in Mali in 2007 to that in 2009?
Give a very brief answer. 0.59. What is the ratio of the Expenses (in $) in Switzerland in 2007 to that in 2009?
Your answer should be compact. 1.97. What is the ratio of the Expenses (in $) of Tunisia in 2007 to that in 2009?
Ensure brevity in your answer.  0.63. What is the ratio of the Expenses (in $) of Egypt, Arab Rep. in 2007 to that in 2010?
Ensure brevity in your answer.  0.91. What is the ratio of the Expenses (in $) in Mali in 2007 to that in 2010?
Make the answer very short. 0.62. What is the ratio of the Expenses (in $) of Tunisia in 2007 to that in 2010?
Give a very brief answer. 0.61. What is the ratio of the Expenses (in $) of Egypt, Arab Rep. in 2007 to that in 2011?
Provide a short and direct response. 0.73. What is the ratio of the Expenses (in $) of Mali in 2007 to that in 2011?
Provide a succinct answer. 0.98. What is the ratio of the Expenses (in $) of Switzerland in 2007 to that in 2011?
Your answer should be compact. 0.82. What is the ratio of the Expenses (in $) of Tunisia in 2007 to that in 2011?
Give a very brief answer. 0.54. What is the ratio of the Expenses (in $) of Egypt, Arab Rep. in 2008 to that in 2009?
Ensure brevity in your answer.  0.88. What is the ratio of the Expenses (in $) in Mali in 2008 to that in 2009?
Provide a short and direct response. 0.79. What is the ratio of the Expenses (in $) in Switzerland in 2008 to that in 2009?
Provide a short and direct response. 1.11. What is the ratio of the Expenses (in $) in Tunisia in 2008 to that in 2009?
Keep it short and to the point. 0.82. What is the ratio of the Expenses (in $) in Egypt, Arab Rep. in 2008 to that in 2010?
Provide a short and direct response. 0.9. What is the ratio of the Expenses (in $) in Mali in 2008 to that in 2010?
Provide a succinct answer. 0.84. What is the ratio of the Expenses (in $) of Switzerland in 2008 to that in 2010?
Offer a very short reply. 0.55. What is the ratio of the Expenses (in $) of Tunisia in 2008 to that in 2010?
Offer a very short reply. 0.79. What is the ratio of the Expenses (in $) in Egypt, Arab Rep. in 2008 to that in 2011?
Provide a succinct answer. 0.72. What is the ratio of the Expenses (in $) in Mali in 2008 to that in 2011?
Provide a succinct answer. 1.32. What is the ratio of the Expenses (in $) of Switzerland in 2008 to that in 2011?
Provide a short and direct response. 0.46. What is the ratio of the Expenses (in $) in Tunisia in 2008 to that in 2011?
Make the answer very short. 0.71. What is the ratio of the Expenses (in $) in Egypt, Arab Rep. in 2009 to that in 2010?
Your answer should be very brief. 1.02. What is the ratio of the Expenses (in $) of Mali in 2009 to that in 2010?
Keep it short and to the point. 1.06. What is the ratio of the Expenses (in $) of Switzerland in 2009 to that in 2010?
Offer a terse response. 0.49. What is the ratio of the Expenses (in $) in Tunisia in 2009 to that in 2010?
Provide a succinct answer. 0.97. What is the ratio of the Expenses (in $) of Egypt, Arab Rep. in 2009 to that in 2011?
Keep it short and to the point. 0.82. What is the ratio of the Expenses (in $) of Mali in 2009 to that in 2011?
Your response must be concise. 1.67. What is the ratio of the Expenses (in $) in Switzerland in 2009 to that in 2011?
Your answer should be compact. 0.42. What is the ratio of the Expenses (in $) of Tunisia in 2009 to that in 2011?
Provide a short and direct response. 0.86. What is the ratio of the Expenses (in $) of Egypt, Arab Rep. in 2010 to that in 2011?
Provide a succinct answer. 0.8. What is the ratio of the Expenses (in $) of Mali in 2010 to that in 2011?
Make the answer very short. 1.57. What is the ratio of the Expenses (in $) in Switzerland in 2010 to that in 2011?
Make the answer very short. 0.84. What is the ratio of the Expenses (in $) of Tunisia in 2010 to that in 2011?
Ensure brevity in your answer.  0.89. What is the difference between the highest and the second highest Expenses (in $) of Egypt, Arab Rep.?
Your answer should be very brief. 5.96e+09. What is the difference between the highest and the second highest Expenses (in $) of Mali?
Give a very brief answer. 6.42e+09. What is the difference between the highest and the second highest Expenses (in $) of Switzerland?
Keep it short and to the point. 1.09e+09. What is the difference between the highest and the second highest Expenses (in $) of Tunisia?
Your answer should be very brief. 2.50e+08. What is the difference between the highest and the lowest Expenses (in $) of Egypt, Arab Rep.?
Provide a succinct answer. 1.35e+1. What is the difference between the highest and the lowest Expenses (in $) of Mali?
Give a very brief answer. 4.68e+1. What is the difference between the highest and the lowest Expenses (in $) in Switzerland?
Your answer should be very brief. 4.09e+09. What is the difference between the highest and the lowest Expenses (in $) in Tunisia?
Ensure brevity in your answer.  1.20e+09. 